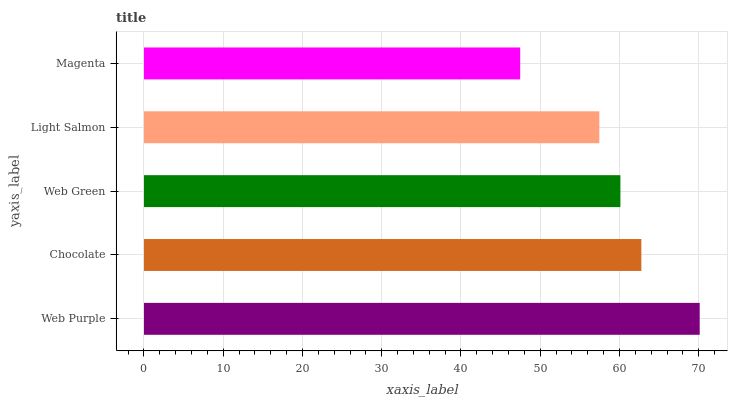Is Magenta the minimum?
Answer yes or no. Yes. Is Web Purple the maximum?
Answer yes or no. Yes. Is Chocolate the minimum?
Answer yes or no. No. Is Chocolate the maximum?
Answer yes or no. No. Is Web Purple greater than Chocolate?
Answer yes or no. Yes. Is Chocolate less than Web Purple?
Answer yes or no. Yes. Is Chocolate greater than Web Purple?
Answer yes or no. No. Is Web Purple less than Chocolate?
Answer yes or no. No. Is Web Green the high median?
Answer yes or no. Yes. Is Web Green the low median?
Answer yes or no. Yes. Is Chocolate the high median?
Answer yes or no. No. Is Web Purple the low median?
Answer yes or no. No. 